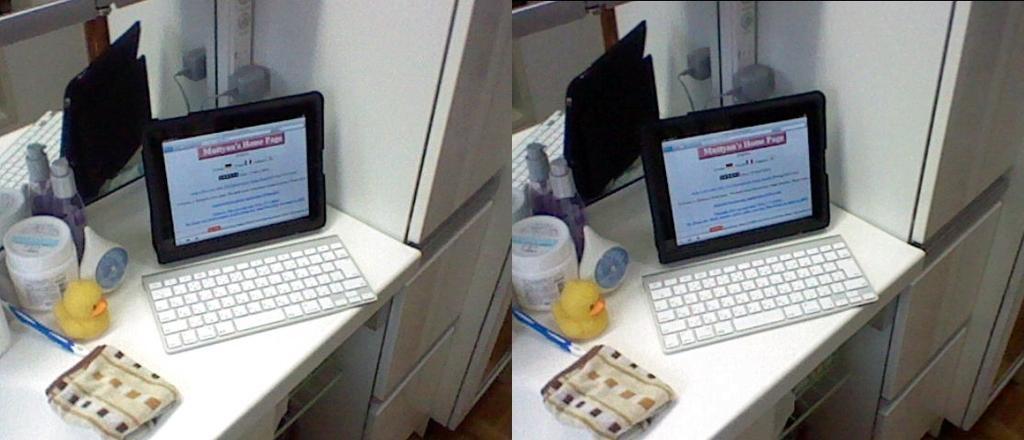Can you describe this image briefly? This is a collage of two images. But two images are same. In the image there is a table. On the table there is a keyboard, computer, towel, brush, bottles, a toy, socket and a mirror. And there are cupboards. 